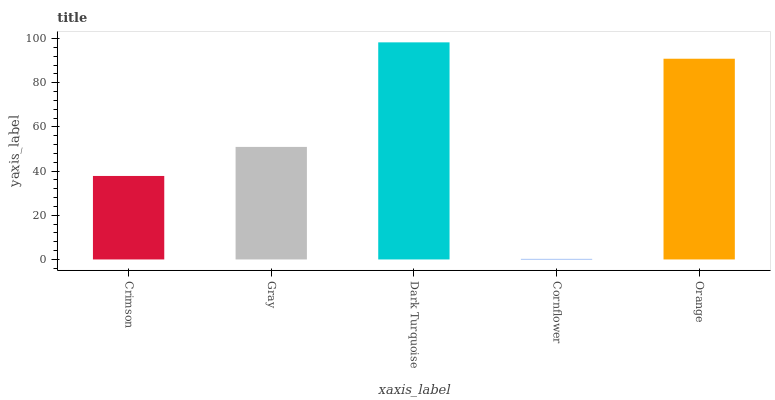Is Cornflower the minimum?
Answer yes or no. Yes. Is Dark Turquoise the maximum?
Answer yes or no. Yes. Is Gray the minimum?
Answer yes or no. No. Is Gray the maximum?
Answer yes or no. No. Is Gray greater than Crimson?
Answer yes or no. Yes. Is Crimson less than Gray?
Answer yes or no. Yes. Is Crimson greater than Gray?
Answer yes or no. No. Is Gray less than Crimson?
Answer yes or no. No. Is Gray the high median?
Answer yes or no. Yes. Is Gray the low median?
Answer yes or no. Yes. Is Orange the high median?
Answer yes or no. No. Is Dark Turquoise the low median?
Answer yes or no. No. 